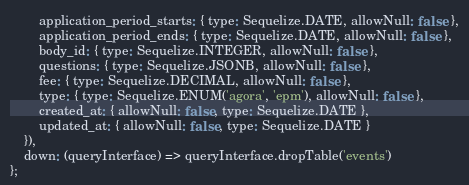Convert code to text. <code><loc_0><loc_0><loc_500><loc_500><_JavaScript_>        application_period_starts: { type: Sequelize.DATE, allowNull: false },
        application_period_ends: { type: Sequelize.DATE, allowNull: false },
        body_id: { type: Sequelize.INTEGER, allowNull: false },
        questions: { type: Sequelize.JSONB, allowNull: false },
        fee: { type: Sequelize.DECIMAL, allowNull: false },
        type: { type: Sequelize.ENUM('agora', 'epm'), allowNull: false },
        created_at: { allowNull: false, type: Sequelize.DATE },
        updated_at: { allowNull: false, type: Sequelize.DATE }
    }),
    down: (queryInterface) => queryInterface.dropTable('events')
};
</code> 